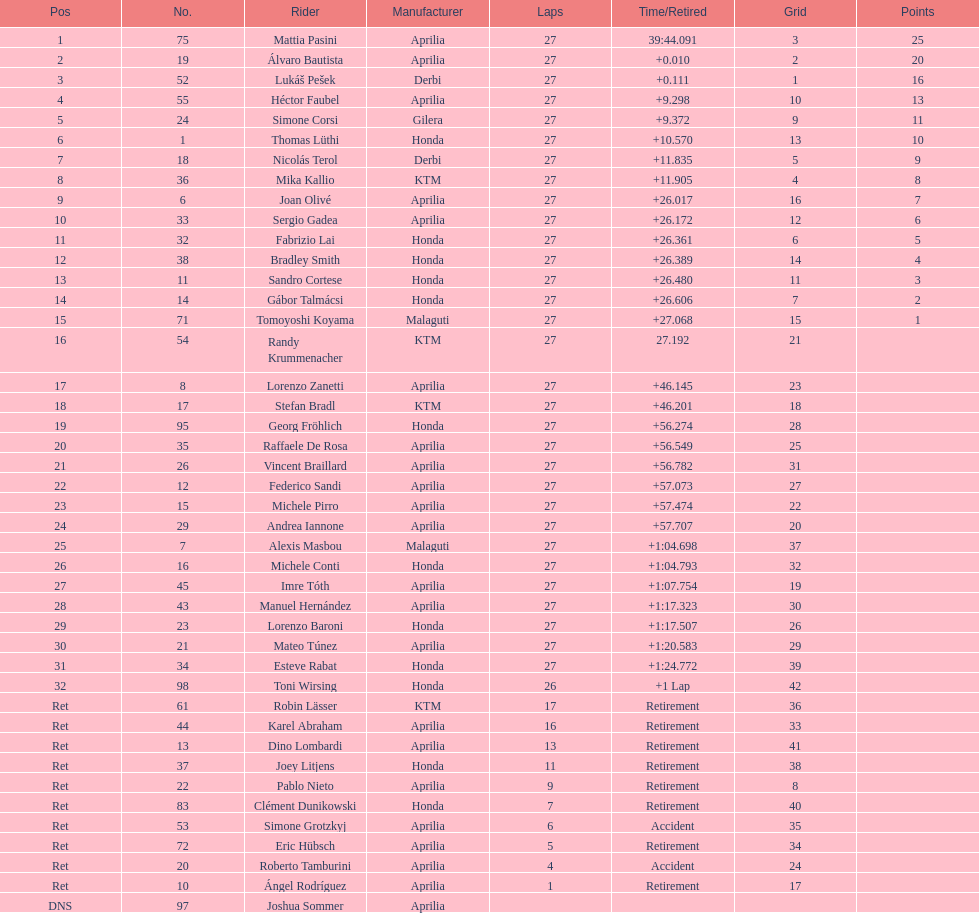Who ranked higher, bradl or gadea? Sergio Gadea. 